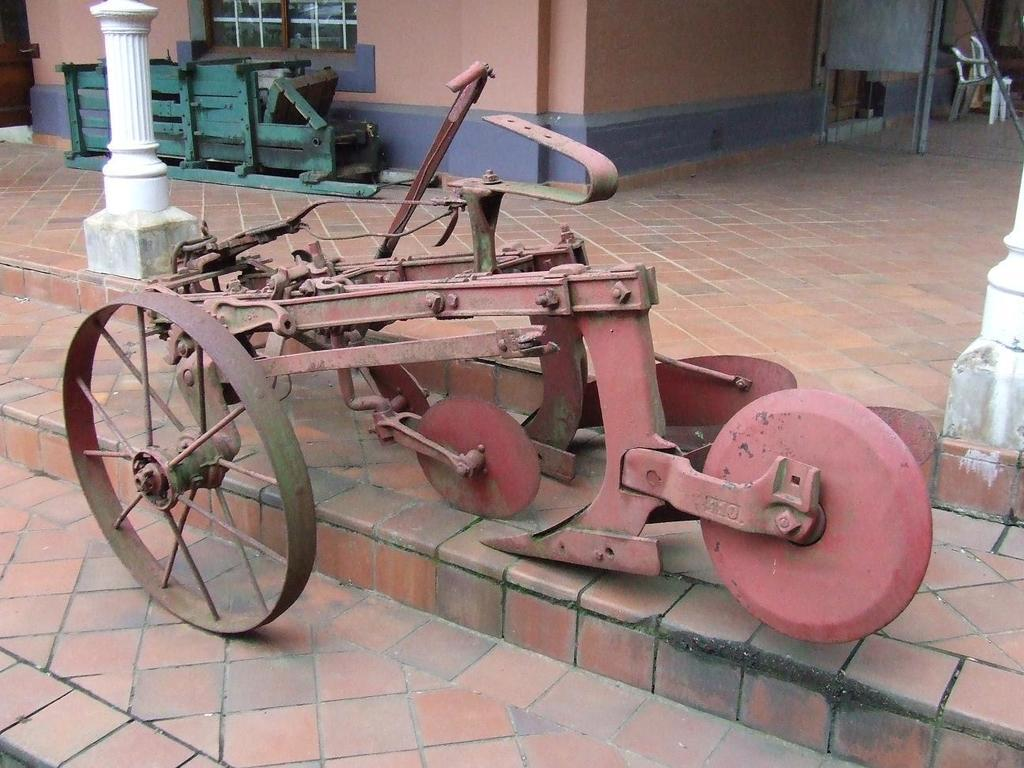What is the main subject of the image? The main subject of the image is a cart on steps. What architectural features can be seen in the image? There is a pillar, a window, and walls visible in the image. What is on the floor in the image? There is an object on the floor in the image. What type of furniture is visible in the background of the image? There are chairs in the background of the image. What other objects can be seen in the background of the image? There are other objects visible in the background of the image. What plot of land is the cart on in the image? The image does not provide information about the plot of land where the cart is located. What type of pipe is visible in the image? There is no pipe visible in the image. 